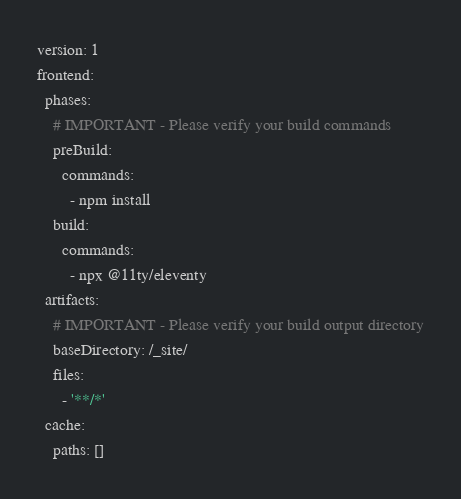<code> <loc_0><loc_0><loc_500><loc_500><_YAML_>version: 1
frontend:
  phases:
    # IMPORTANT - Please verify your build commands
    preBuild:
      commands:
        - npm install
    build:
      commands:
        - npx @11ty/eleventy
  artifacts:
    # IMPORTANT - Please verify your build output directory
    baseDirectory: /_site/
    files:
      - '**/*'
  cache:
    paths: []
</code> 